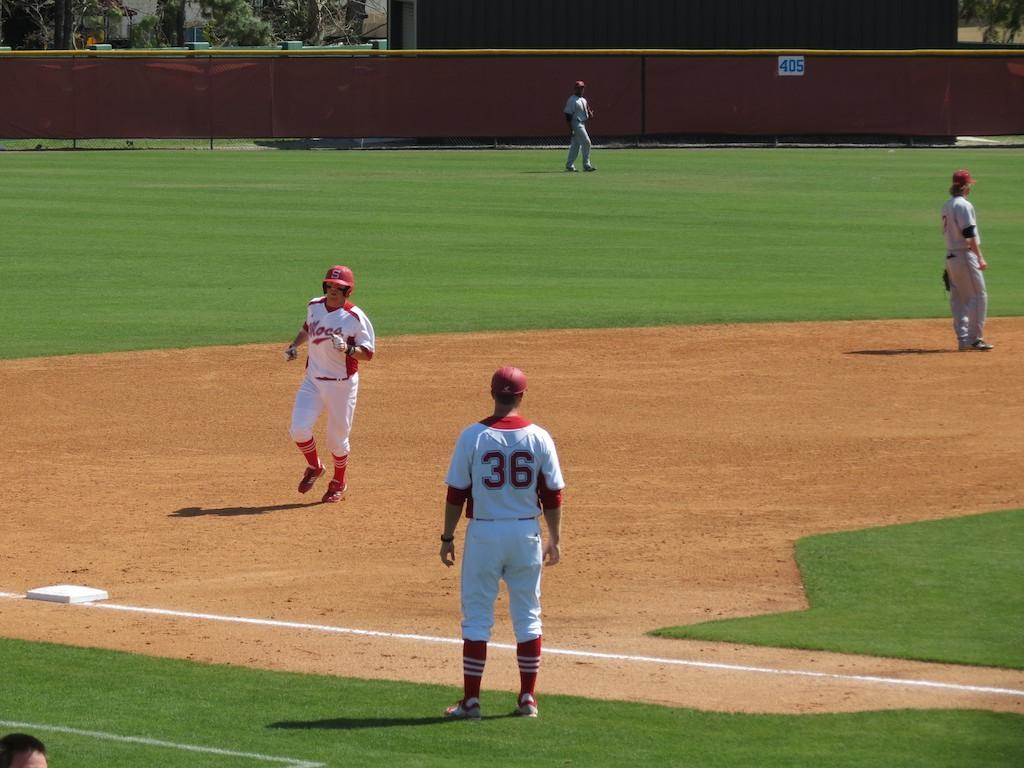Provide a one-sentence caption for the provided image. Baseball players on a field one of the players have 36 on their jersey. 